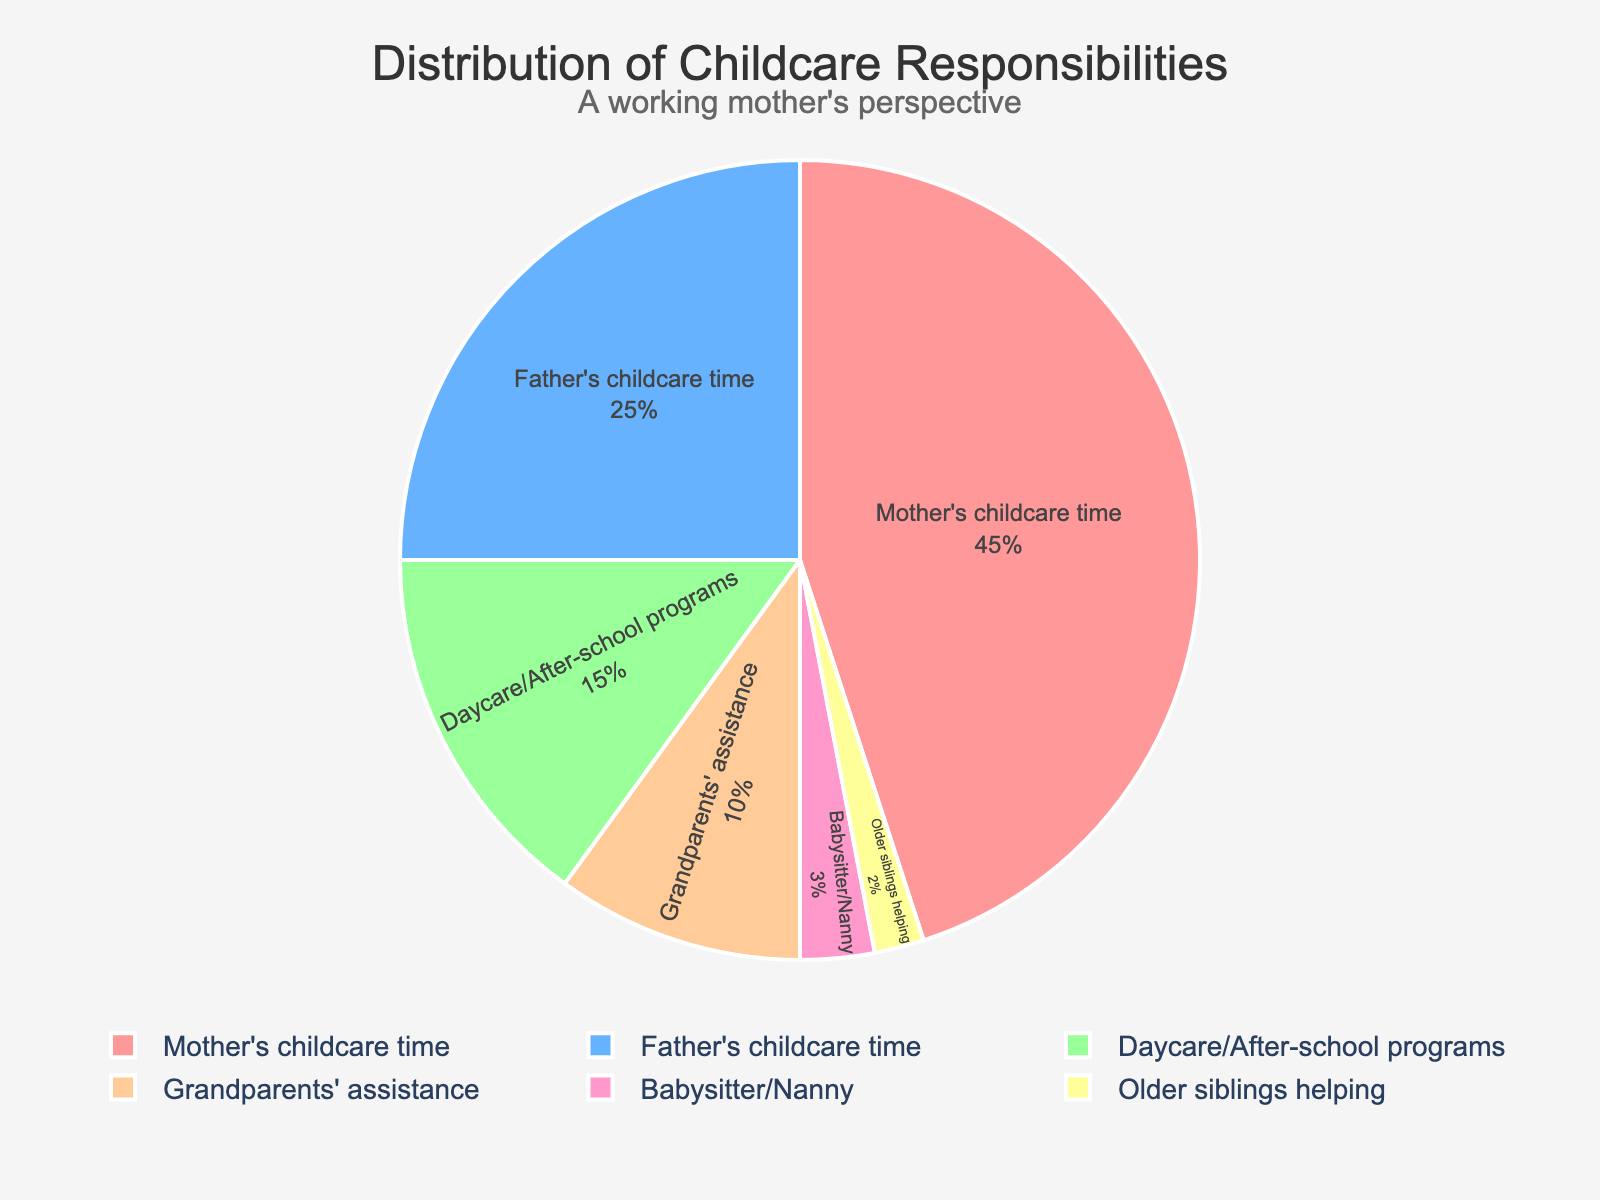Which category has the highest percentage of childcare responsibilities? Look at the pie chart and identify the segment with the largest size. The largest segment represents "Mother's childcare time" at 45%.
Answer: Mother's childcare time Which category has the smallest contribution to childcare responsibilities? Locate the smallest segment in the pie chart. It represents "Older siblings helping" with a contribution of 2%.
Answer: Older siblings helping What is the difference in childcare contributions between mothers and fathers? Find the percentage values for "Mother's childcare time" (45%) and "Father's childcare time" (25%). Subtract the father's percentage from the mother's percentage: 45% - 25% = 20%.
Answer: 20% What percentage of childcare responsibilities are provided by entities other than parents? Add the percentages for "Grandparents' assistance" (10%), "Daycare/After-school programs" (15%), "Babysitter/Nanny" (3%), and "Older siblings helping" (2%). The total is 10% + 15% + 3% + 2% = 30%.
Answer: 30% Are daycare/after-school programs contributing more to childcare than grandparents? Look at the pie chart. Daycare/After-school programs have a 15% contribution, while Grandparents' assistance has a 10% contribution. Since 15% > 10%, daycare/after-school programs contribute more.
Answer: Yes What is the combined contribution of mothers and fathers to childcare? Add the percentages for "Mother's childcare time" (45%) and "Father's childcare time" (25%). The total is 45% + 25% = 70%.
Answer: 70% How does the contribution of babysitters/nannies compare to that of older siblings? Compare the segments in the pie chart. Babysitters/Nannies contribute 3%, while Older siblings contribute 2%. Since 3% > 2%, babysitters/nannies contribute more.
Answer: Babysitters/Nannies contribute more What percentage of childcare responsibilities are handled by family members (parents and grandparents)? Add the percentages for "Mother's childcare time" (45%), "Father's childcare time" (25%), and "Grandparents' assistance" (10%). The total is 45% + 25% + 10% = 80%.
Answer: 80% How much more do daycare/after-school programs contribute compared to babysitters/nannies? Subtract the percentage of babysitters/nannies (3%) from the percentage of daycare/after-school programs (15%). The difference is 15% - 3% = 12%.
Answer: 12% Which two categories together make up half of the childcare responsibilities? Find two categories whose percentages sum up to 50%. "Mother's childcare time" (45%) and "Daycare/After-school programs" (15%) together make up 45% + 15% = 60%. Since 60% is not 50%, check other combinations: "Mother's childcare time" (45%) and "Father's childcare time" (25%) sum up to 70%. No pairs directly make up 50%. Thus, there are no exact two categories that sum up to half.
Answer: None 